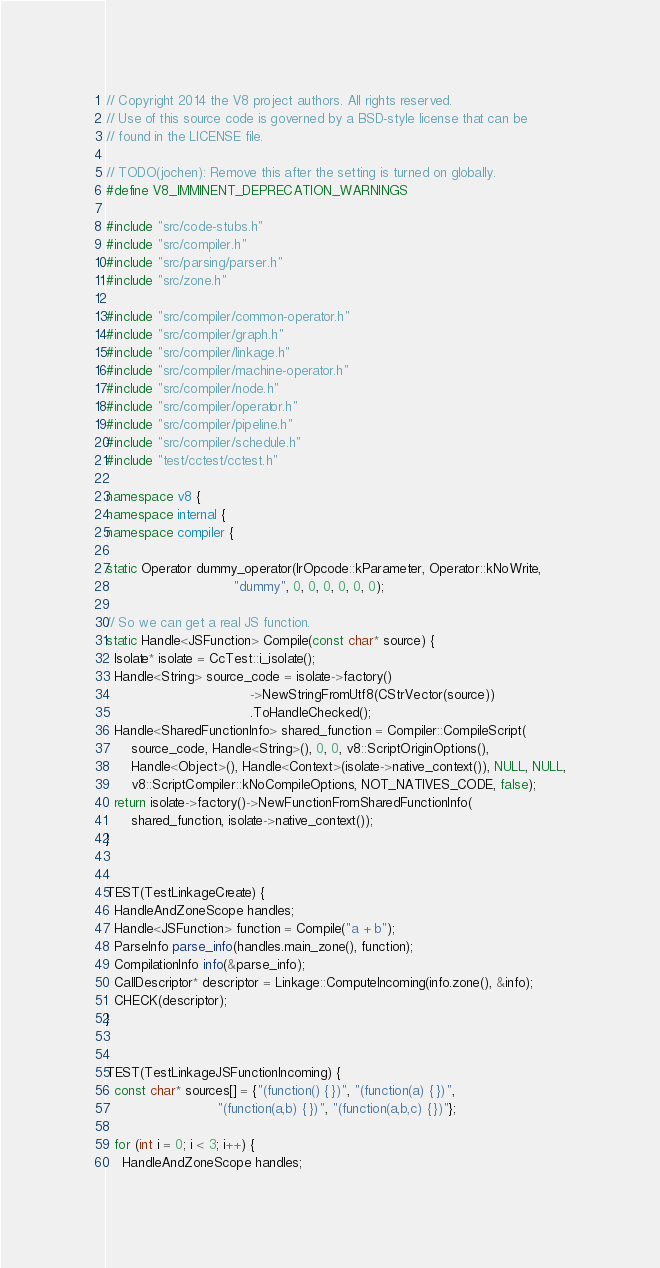<code> <loc_0><loc_0><loc_500><loc_500><_C++_>// Copyright 2014 the V8 project authors. All rights reserved.
// Use of this source code is governed by a BSD-style license that can be
// found in the LICENSE file.

// TODO(jochen): Remove this after the setting is turned on globally.
#define V8_IMMINENT_DEPRECATION_WARNINGS

#include "src/code-stubs.h"
#include "src/compiler.h"
#include "src/parsing/parser.h"
#include "src/zone.h"

#include "src/compiler/common-operator.h"
#include "src/compiler/graph.h"
#include "src/compiler/linkage.h"
#include "src/compiler/machine-operator.h"
#include "src/compiler/node.h"
#include "src/compiler/operator.h"
#include "src/compiler/pipeline.h"
#include "src/compiler/schedule.h"
#include "test/cctest/cctest.h"

namespace v8 {
namespace internal {
namespace compiler {

static Operator dummy_operator(IrOpcode::kParameter, Operator::kNoWrite,
                               "dummy", 0, 0, 0, 0, 0, 0);

// So we can get a real JS function.
static Handle<JSFunction> Compile(const char* source) {
  Isolate* isolate = CcTest::i_isolate();
  Handle<String> source_code = isolate->factory()
                                   ->NewStringFromUtf8(CStrVector(source))
                                   .ToHandleChecked();
  Handle<SharedFunctionInfo> shared_function = Compiler::CompileScript(
      source_code, Handle<String>(), 0, 0, v8::ScriptOriginOptions(),
      Handle<Object>(), Handle<Context>(isolate->native_context()), NULL, NULL,
      v8::ScriptCompiler::kNoCompileOptions, NOT_NATIVES_CODE, false);
  return isolate->factory()->NewFunctionFromSharedFunctionInfo(
      shared_function, isolate->native_context());
}


TEST(TestLinkageCreate) {
  HandleAndZoneScope handles;
  Handle<JSFunction> function = Compile("a + b");
  ParseInfo parse_info(handles.main_zone(), function);
  CompilationInfo info(&parse_info);
  CallDescriptor* descriptor = Linkage::ComputeIncoming(info.zone(), &info);
  CHECK(descriptor);
}


TEST(TestLinkageJSFunctionIncoming) {
  const char* sources[] = {"(function() { })", "(function(a) { })",
                           "(function(a,b) { })", "(function(a,b,c) { })"};

  for (int i = 0; i < 3; i++) {
    HandleAndZoneScope handles;</code> 